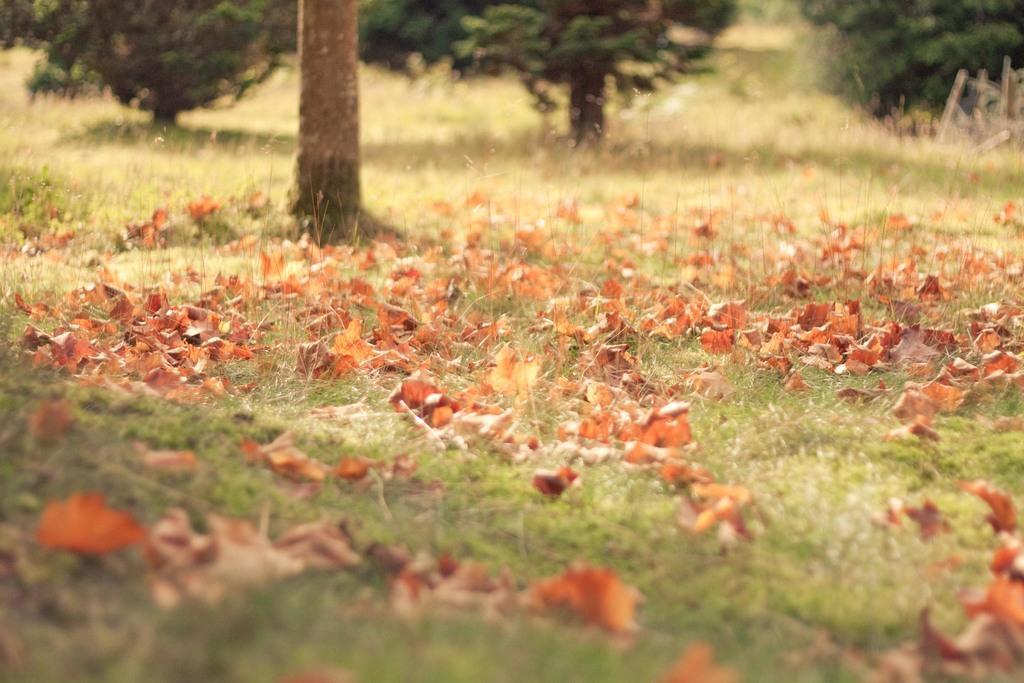In one or two sentences, can you explain what this image depicts? At the bottom of the image on the ground there is grass and also there are dry leaves. In the background there are trees and also there is a tree trunk. 